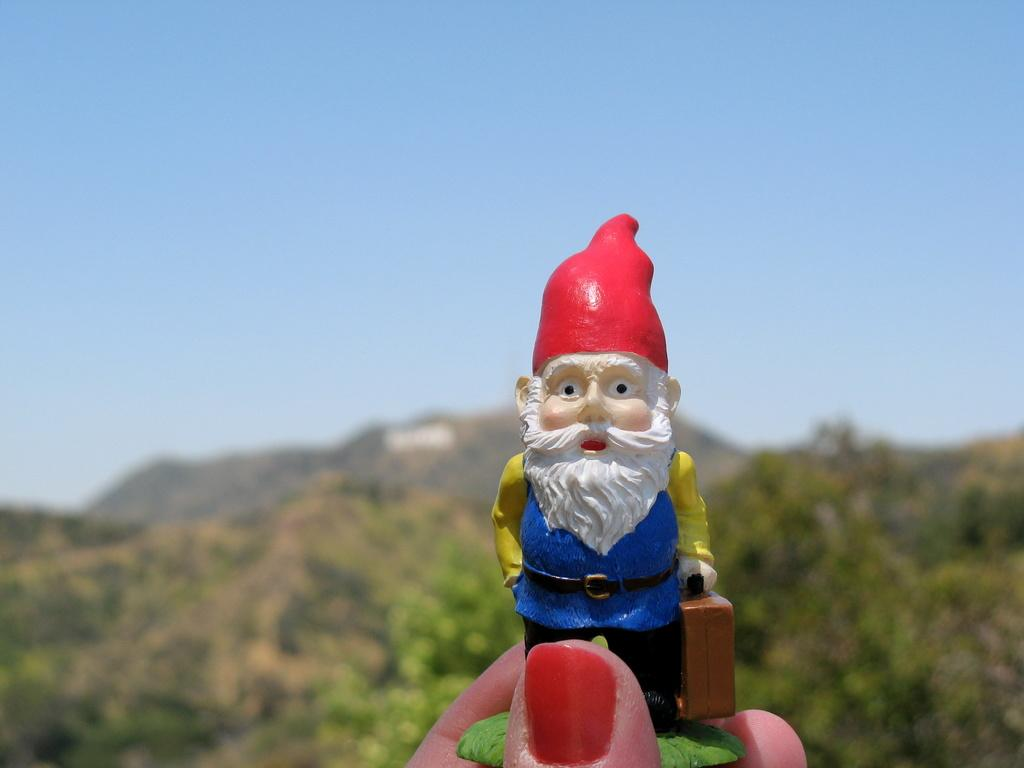What is being held by the person's hand in the image? There is a toy being held by the person's hand in the image. What can be seen in the distance behind the person? There are trees, mountains, and the sky visible in the background of the image. What type of skirt is the bee wearing in the image? There is no bee or skirt present in the image. How many dolls are sitting on the mountains in the image? There are no dolls present in the image; only trees, mountains, and the sky can be seen in the background. 